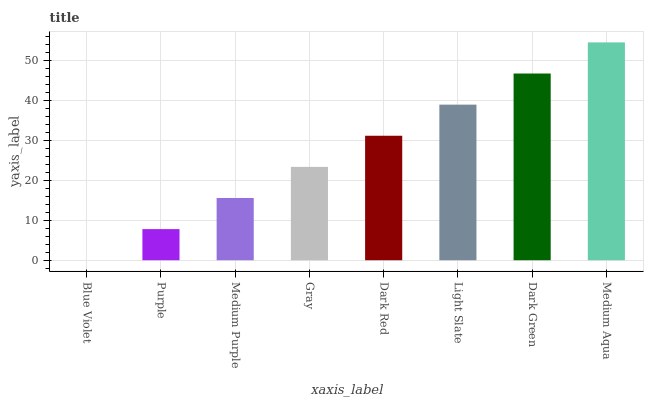Is Purple the minimum?
Answer yes or no. No. Is Purple the maximum?
Answer yes or no. No. Is Purple greater than Blue Violet?
Answer yes or no. Yes. Is Blue Violet less than Purple?
Answer yes or no. Yes. Is Blue Violet greater than Purple?
Answer yes or no. No. Is Purple less than Blue Violet?
Answer yes or no. No. Is Dark Red the high median?
Answer yes or no. Yes. Is Gray the low median?
Answer yes or no. Yes. Is Medium Purple the high median?
Answer yes or no. No. Is Purple the low median?
Answer yes or no. No. 